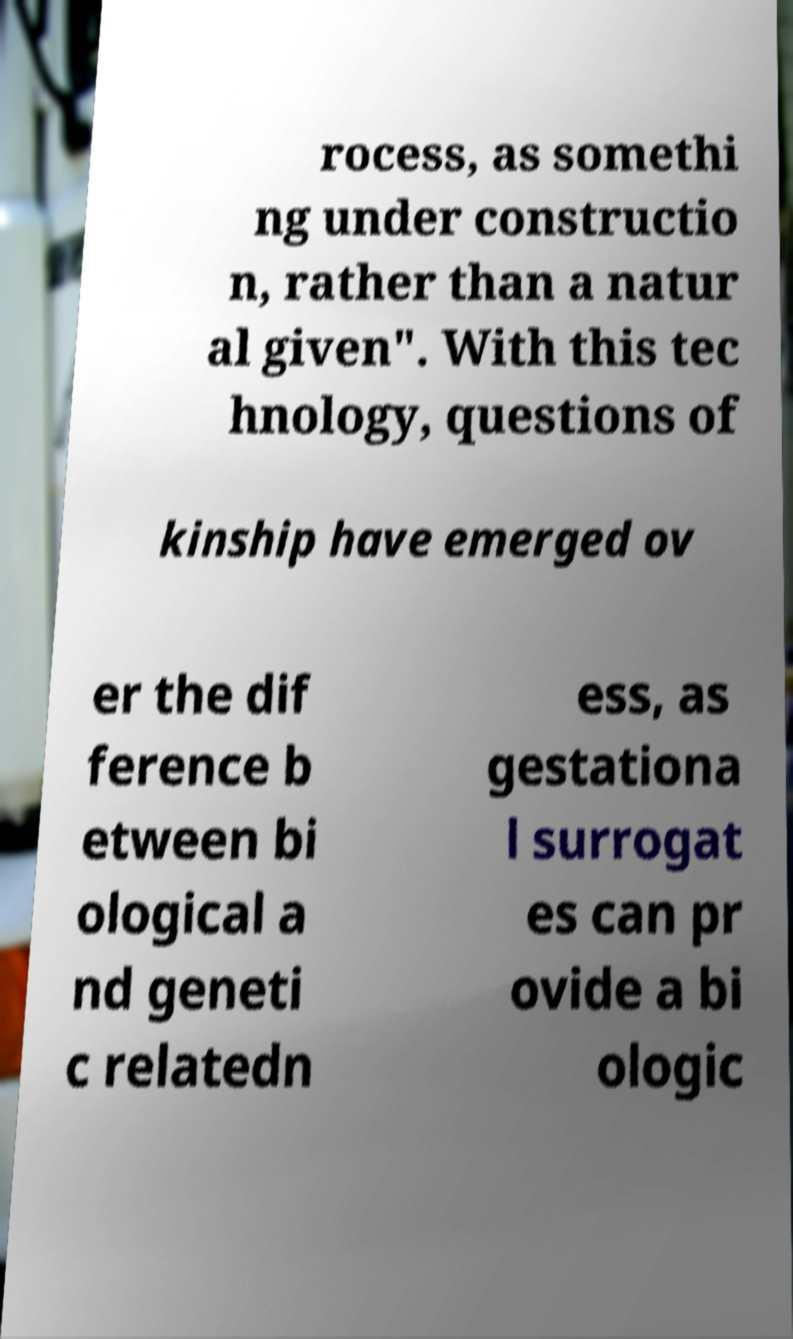I need the written content from this picture converted into text. Can you do that? rocess, as somethi ng under constructio n, rather than a natur al given". With this tec hnology, questions of kinship have emerged ov er the dif ference b etween bi ological a nd geneti c relatedn ess, as gestationa l surrogat es can pr ovide a bi ologic 